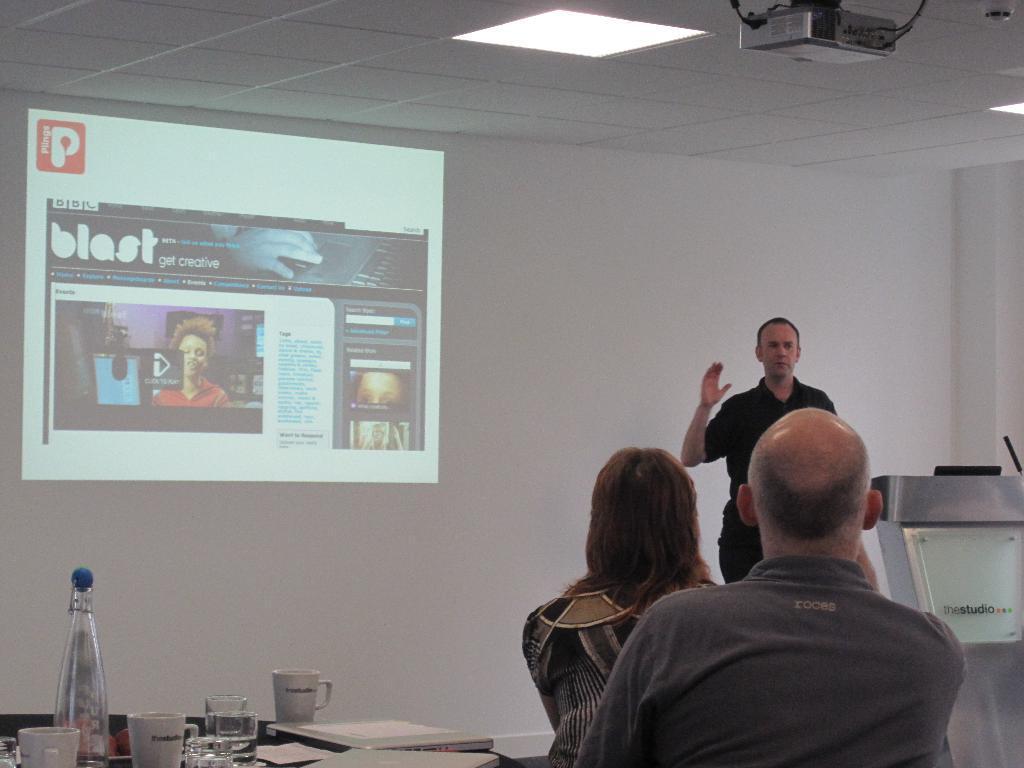Describe this image in one or two sentences. In this picture there is a man standing near the podium, raising his hand. There are two people listening to him beside the table. On the table there are some papers, glasses, bottle. In the background there is a projector screen display on the wall. 